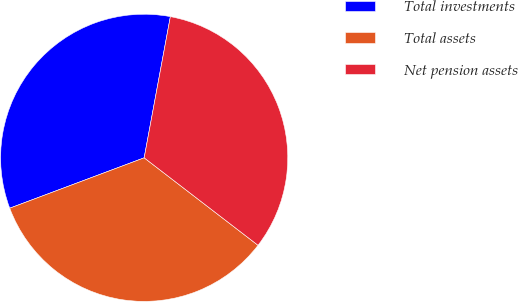Convert chart to OTSL. <chart><loc_0><loc_0><loc_500><loc_500><pie_chart><fcel>Total investments<fcel>Total assets<fcel>Net pension assets<nl><fcel>33.63%<fcel>33.87%<fcel>32.51%<nl></chart> 